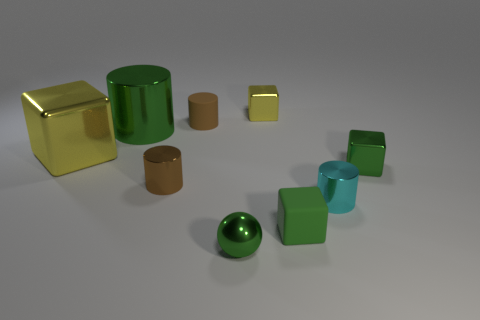Subtract all cyan metallic cylinders. How many cylinders are left? 3 Add 1 large purple rubber things. How many objects exist? 10 Subtract all green cylinders. How many cylinders are left? 3 Subtract all balls. How many objects are left? 8 Subtract all green cylinders. Subtract all yellow blocks. How many cylinders are left? 3 Subtract all purple cubes. How many purple spheres are left? 0 Subtract all big gray shiny cubes. Subtract all cylinders. How many objects are left? 5 Add 9 small green spheres. How many small green spheres are left? 10 Add 5 brown metallic cylinders. How many brown metallic cylinders exist? 6 Subtract 0 red spheres. How many objects are left? 9 